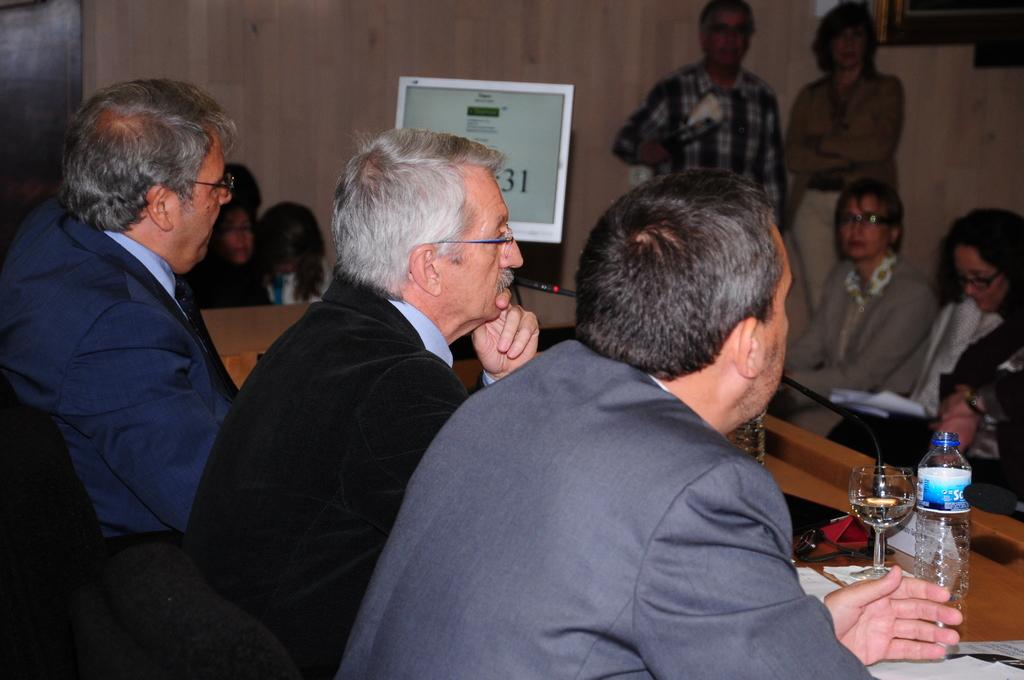How many people are in the image? There are people in the image, but the exact number is not specified. What are the positions of the people in the image? Two of the people are standing, and the rest are sitting. What type of containers are visible in the image? There are bottles and a glass in the image. What type of electronic device is present in the image? There is a monitor in the image. What type of battle is taking place in the image? There is no battle present in the image; it features people, containers, and a monitor. Is there a stream visible in the image? There is no stream present in the image. 